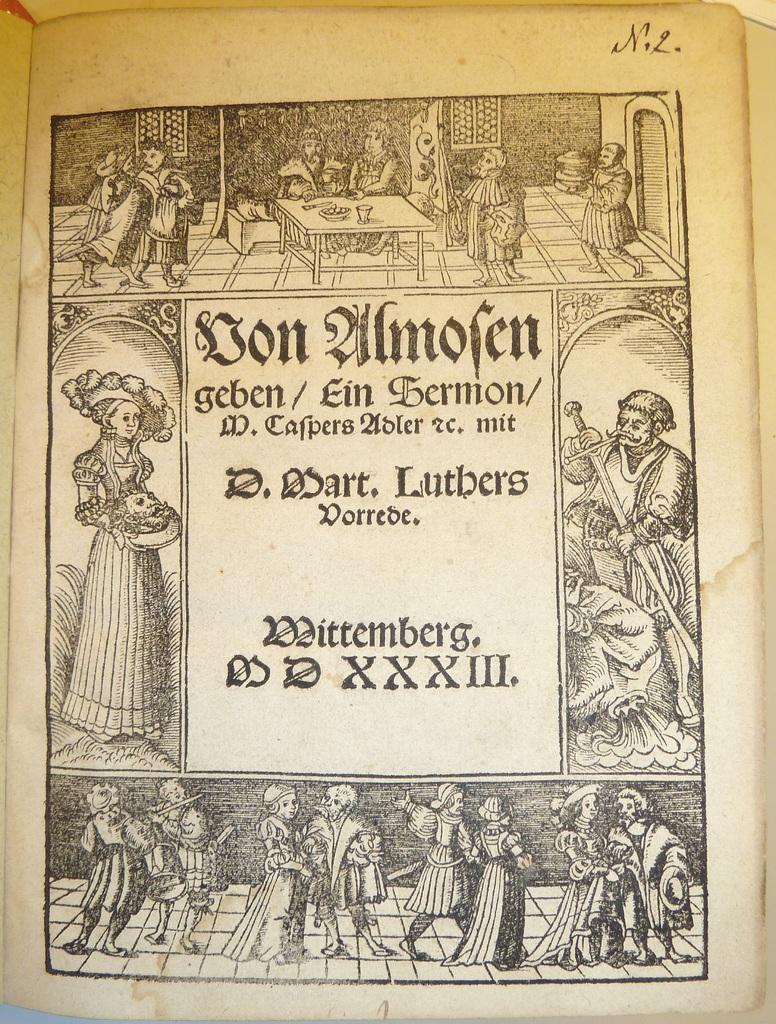Could you give a brief overview of what you see in this image? This is a paper. In this we can see some persons, table, objects, wall, door, windows, floor and some text. 